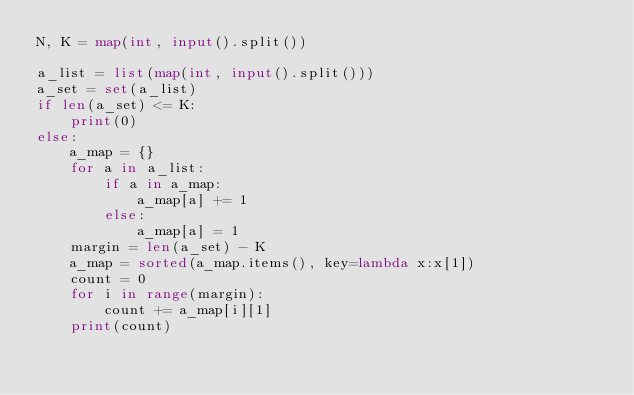Convert code to text. <code><loc_0><loc_0><loc_500><loc_500><_Python_>N, K = map(int, input().split())

a_list = list(map(int, input().split()))
a_set = set(a_list)
if len(a_set) <= K:
    print(0)
else:
    a_map = {}
    for a in a_list:
        if a in a_map:
            a_map[a] += 1
        else:
            a_map[a] = 1
    margin = len(a_set) - K
    a_map = sorted(a_map.items(), key=lambda x:x[1])
    count = 0
    for i in range(margin):
        count += a_map[i][1]
    print(count)</code> 